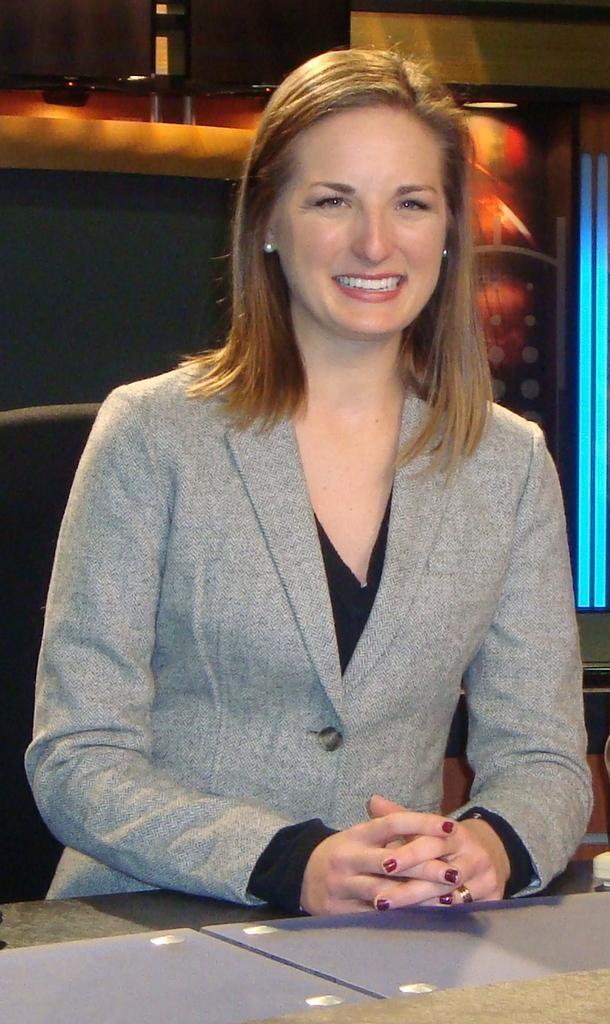How would you summarize this image in a sentence or two? In this image I can see a woman is sitting on a chair in front of a table. In the background, I can see some objects and a wall. This image is taken may be in a hall. 